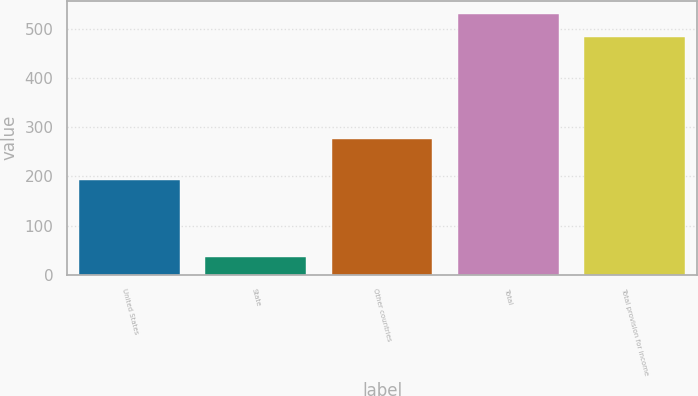Convert chart to OTSL. <chart><loc_0><loc_0><loc_500><loc_500><bar_chart><fcel>United States<fcel>State<fcel>Other countries<fcel>Total<fcel>Total provision for income<nl><fcel>192<fcel>35.4<fcel>275.9<fcel>530.69<fcel>483.9<nl></chart> 